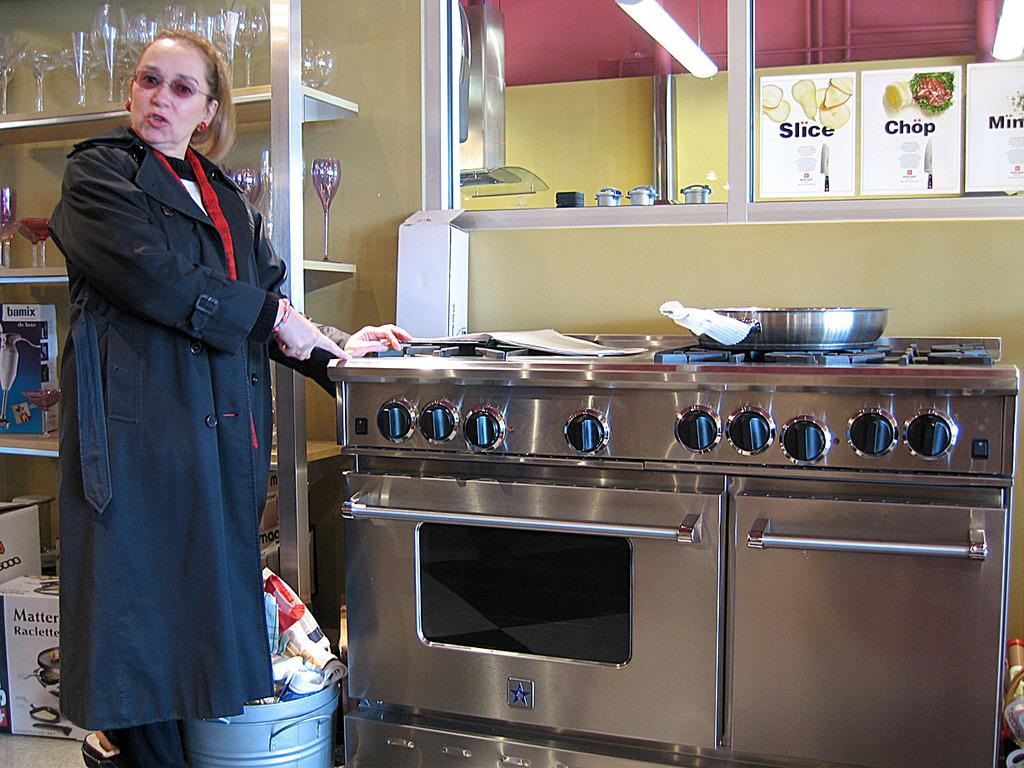<image>
Describe the image concisely. signs above a stove that says 'slice' and 'chop' on them 